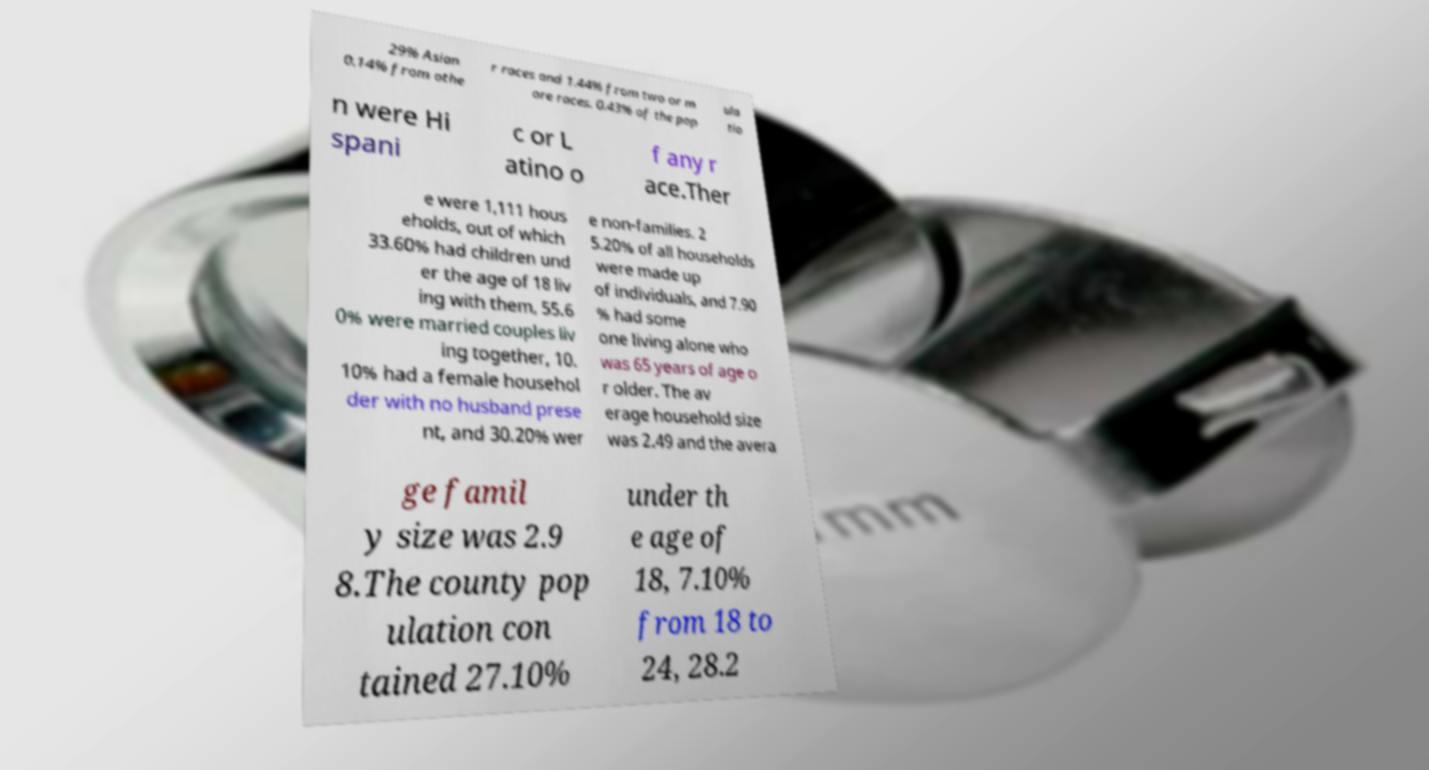I need the written content from this picture converted into text. Can you do that? 29% Asian 0.14% from othe r races and 1.44% from two or m ore races. 0.43% of the pop ula tio n were Hi spani c or L atino o f any r ace.Ther e were 1,111 hous eholds, out of which 33.60% had children und er the age of 18 liv ing with them, 55.6 0% were married couples liv ing together, 10. 10% had a female househol der with no husband prese nt, and 30.20% wer e non-families. 2 5.20% of all households were made up of individuals, and 7.90 % had some one living alone who was 65 years of age o r older. The av erage household size was 2.49 and the avera ge famil y size was 2.9 8.The county pop ulation con tained 27.10% under th e age of 18, 7.10% from 18 to 24, 28.2 